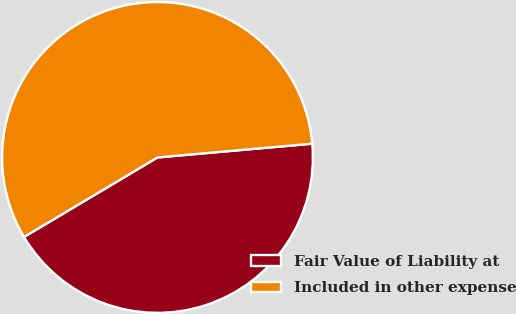<chart> <loc_0><loc_0><loc_500><loc_500><pie_chart><fcel>Fair Value of Liability at<fcel>Included in other expense<nl><fcel>42.86%<fcel>57.14%<nl></chart> 